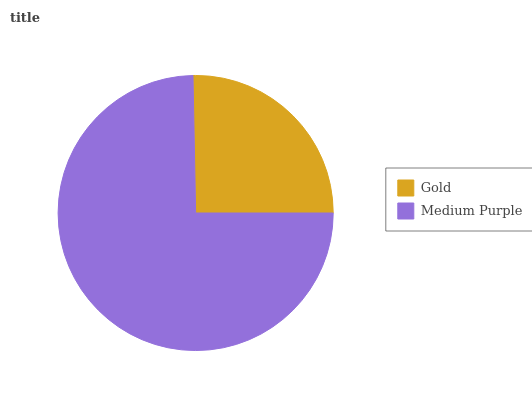Is Gold the minimum?
Answer yes or no. Yes. Is Medium Purple the maximum?
Answer yes or no. Yes. Is Medium Purple the minimum?
Answer yes or no. No. Is Medium Purple greater than Gold?
Answer yes or no. Yes. Is Gold less than Medium Purple?
Answer yes or no. Yes. Is Gold greater than Medium Purple?
Answer yes or no. No. Is Medium Purple less than Gold?
Answer yes or no. No. Is Medium Purple the high median?
Answer yes or no. Yes. Is Gold the low median?
Answer yes or no. Yes. Is Gold the high median?
Answer yes or no. No. Is Medium Purple the low median?
Answer yes or no. No. 